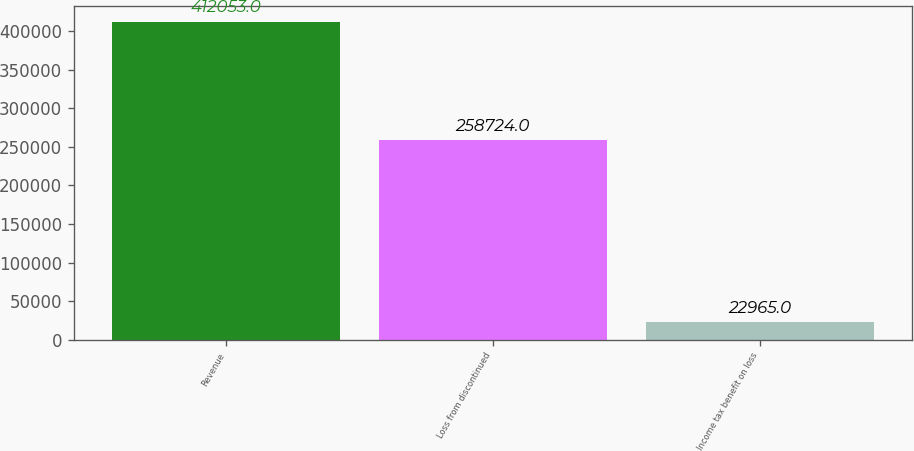Convert chart. <chart><loc_0><loc_0><loc_500><loc_500><bar_chart><fcel>Revenue<fcel>Loss from discontinued<fcel>Income tax benefit on loss<nl><fcel>412053<fcel>258724<fcel>22965<nl></chart> 